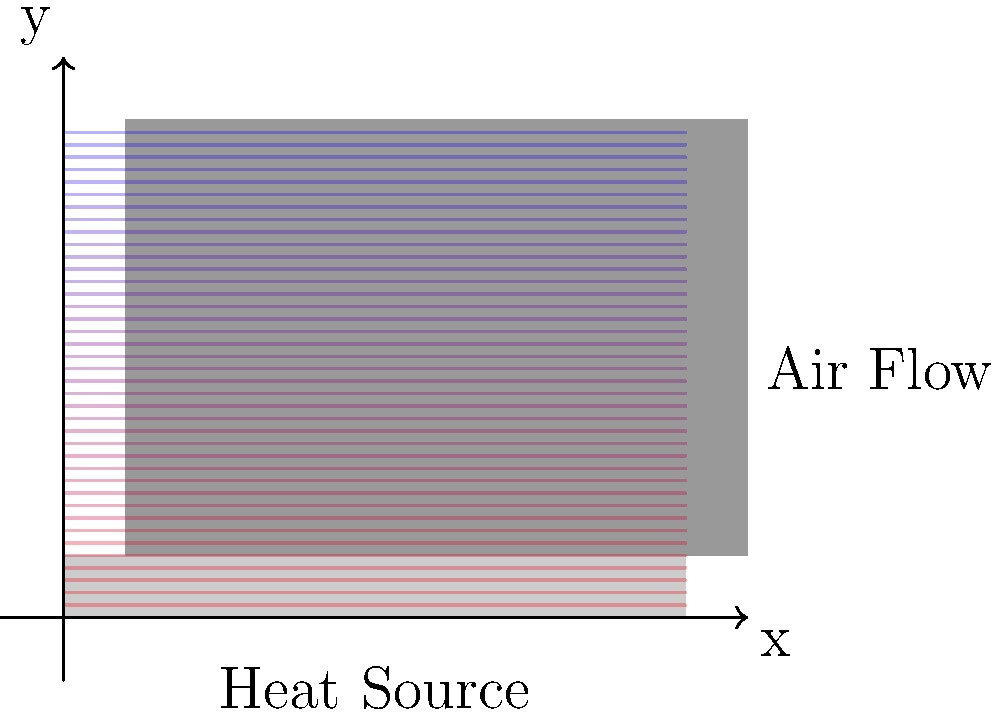In your latest animated short film, you're depicting a futuristic cooling system for a supercomputer. You've drawn a heat sink with multiple fins, similar to the one shown above. If the base temperature of the heat sink is $100°C$ and the ambient air temperature is $25°C$, how would you illustrate the temperature distribution along a single fin, assuming it follows the equation $T(x) = T_{base} - (T_{base} - T_{ambient}) \cdot \frac{\cosh(m(L-x))}{\cosh(mL)}$, where $m = \sqrt{\frac{2h}{kt}}$, $L$ is the fin length, $k$ is the thermal conductivity, $t$ is the fin thickness, and $h$ is the convective heat transfer coefficient? To illustrate the temperature distribution along a single fin, we need to follow these steps:

1) Identify the given parameters:
   $T_{base} = 100°C$
   $T_{ambient} = 25°C$
   $L$ = fin length (visible in the image)
   
2) The temperature distribution equation is:
   $T(x) = T_{base} - (T_{base} - T_{ambient}) \cdot \frac{\cosh(m(L-x))}{\cosh(mL)}$

3) We don't have specific values for $m$, $k$, $t$, and $h$, but we can understand the general behavior:
   - At $x = 0$ (fin base), $T(0) = T_{base} = 100°C$
   - As $x$ increases (moving up the fin), $T(x)$ decreases
   - At $x = L$ (fin tip), $T(L)$ will be closest to $T_{ambient}$, but not exactly $25°C$

4) The $\cosh$ function in the equation creates a non-linear temperature drop along the fin:
   - Temperature drops more rapidly near the base
   - Temperature change slows down towards the tip

5) To illustrate this in your animation:
   - Use a color gradient from red (hot) at the base to blue (cool) at the tip
   - Make the color change more pronounced near the base
   - Show a gradual color transition towards the tip
   - Ensure the tip color is slightly warmer than the ambient air color

6) You could add small arrows or lines to show heat dissipation from the fins to the air, with more heat being released near the base.
Answer: Illustrate with a non-linear color gradient from red (base) to blue (tip), with faster color change near the base and slower change towards the tip. 